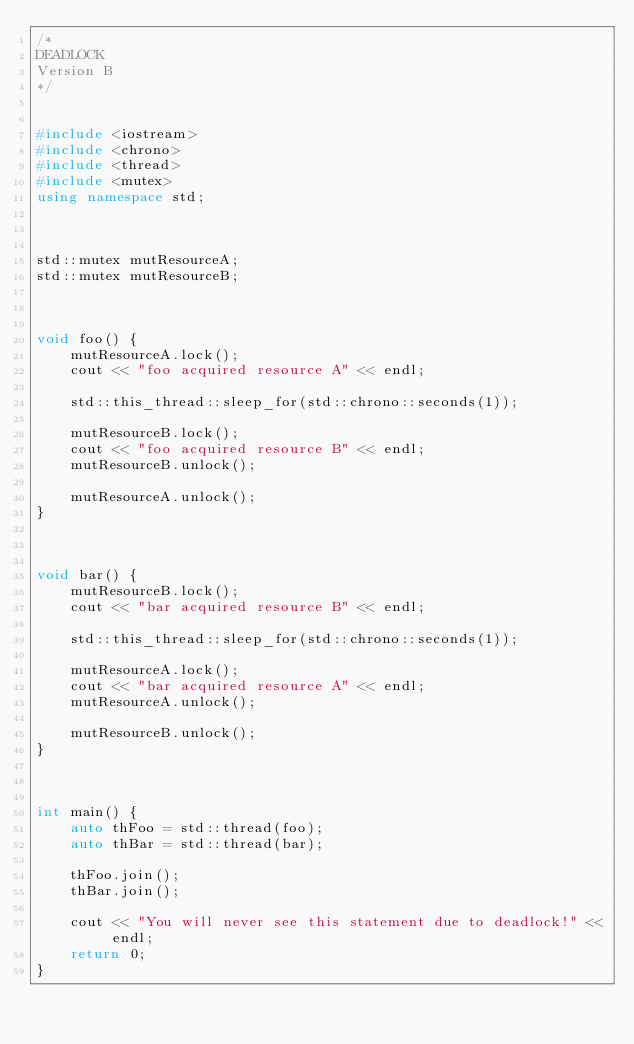Convert code to text. <code><loc_0><loc_0><loc_500><loc_500><_C++_>/*
DEADLOCK
Version B
*/


#include <iostream>
#include <chrono>
#include <thread>
#include <mutex>
using namespace std;



std::mutex mutResourceA;
std::mutex mutResourceB;



void foo() {
    mutResourceA.lock();
    cout << "foo acquired resource A" << endl;

    std::this_thread::sleep_for(std::chrono::seconds(1));

    mutResourceB.lock();
    cout << "foo acquired resource B" << endl;
    mutResourceB.unlock();

    mutResourceA.unlock();
}



void bar() {
    mutResourceB.lock();
    cout << "bar acquired resource B" << endl;

    std::this_thread::sleep_for(std::chrono::seconds(1));

    mutResourceA.lock();
    cout << "bar acquired resource A" << endl;
    mutResourceA.unlock();

    mutResourceB.unlock();
}



int main() {
    auto thFoo = std::thread(foo);
    auto thBar = std::thread(bar);

    thFoo.join();
    thBar.join();

    cout << "You will never see this statement due to deadlock!" << endl;
    return 0;
}
</code> 